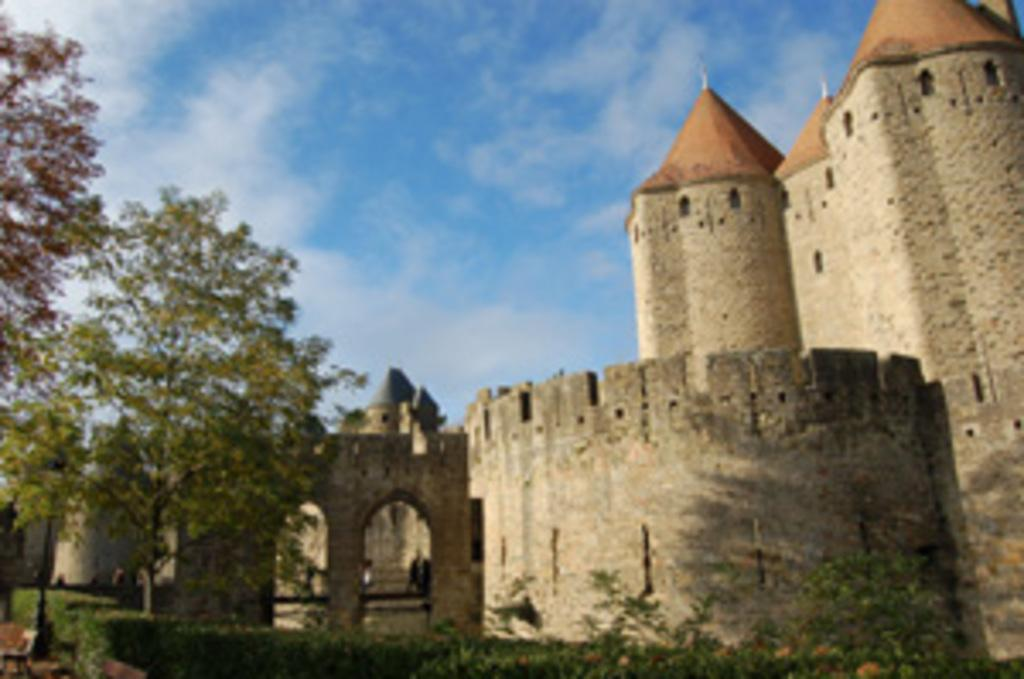What type of structure is present in the image? There is a fort in the image. What other type of structure can be seen in the image? There is a building in the image. What colors are used for the building? The building is in cream and brown color. What type of vegetation is present in the image? There are trees in the image. What type of seating is available in the image? There is a bench in the image. What is the color of the sky in the image? The sky is blue and white in color. What type of rhythm can be heard coming from the fort in the image? There is no indication of any sound or rhythm in the image, as it is a still photograph. 